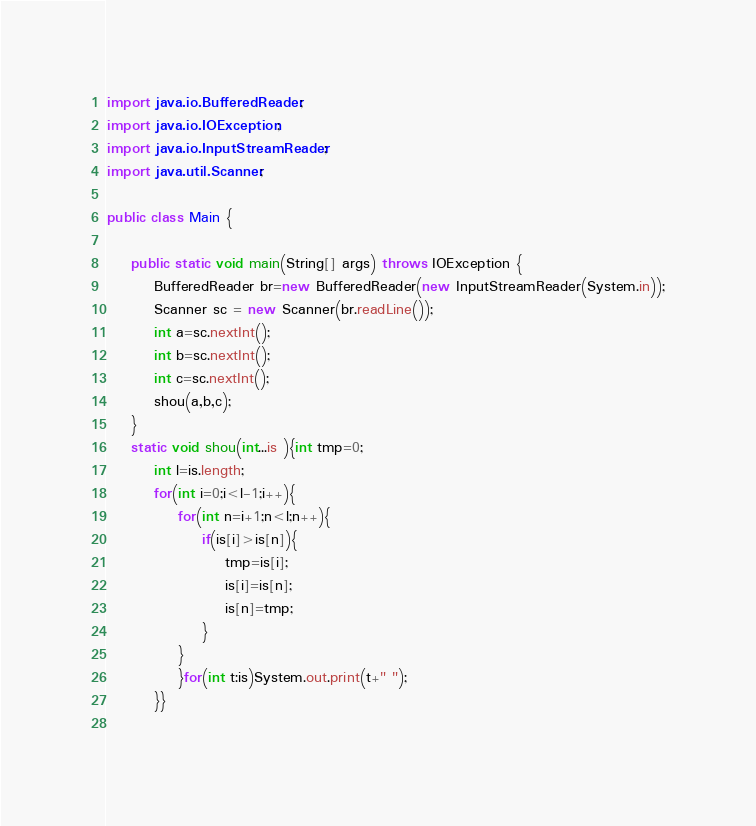<code> <loc_0><loc_0><loc_500><loc_500><_Java_>
import java.io.BufferedReader;
import java.io.IOException;
import java.io.InputStreamReader;
import java.util.Scanner;

public class Main {

	public static void main(String[] args) throws IOException {
		BufferedReader br=new BufferedReader(new InputStreamReader(System.in));
		Scanner sc = new Scanner(br.readLine());
		int a=sc.nextInt();
		int b=sc.nextInt();
		int c=sc.nextInt();
		shou(a,b,c);
	}
	static void shou(int...is ){int tmp=0;
		int l=is.length;
		for(int i=0;i<l-1;i++){
			for(int n=i+1;n<l;n++){
				if(is[i]>is[n]){
					tmp=is[i];
					is[i]=is[n];
					is[n]=tmp;
				}
			}
			}for(int t:is)System.out.print(t+" ");
		}}
	</code> 